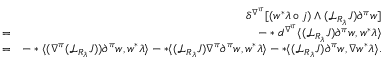Convert formula to latex. <formula><loc_0><loc_0><loc_500><loc_500>\begin{array} { r l r } & { \delta ^ { \nabla ^ { \pi } } [ ( w ^ { * } \lambda \circ j ) \wedge ( { \mathcal { L } } _ { R _ { \lambda } } J ) \partial ^ { \pi } w ] } \\ & { = } & { - * d ^ { \nabla ^ { \pi } } \langle ( { \mathcal { L } } _ { R _ { \lambda } } J ) \partial ^ { \pi } w , w ^ { * } \lambda \rangle } \\ & { = } & { - * \langle ( \nabla ^ { \pi } ( { \mathcal { L } } _ { R _ { \lambda } } J ) ) \partial ^ { \pi } w , w ^ { * } \lambda \rangle - * \langle ( { \mathcal { L } } _ { R _ { \lambda } } J ) \nabla ^ { \pi } \partial ^ { \pi } w , w ^ { * } \lambda \rangle - * \langle ( { \mathcal { L } } _ { R _ { \lambda } } J ) \partial ^ { \pi } w , \nabla w ^ { * } \lambda \rangle . } \end{array}</formula> 